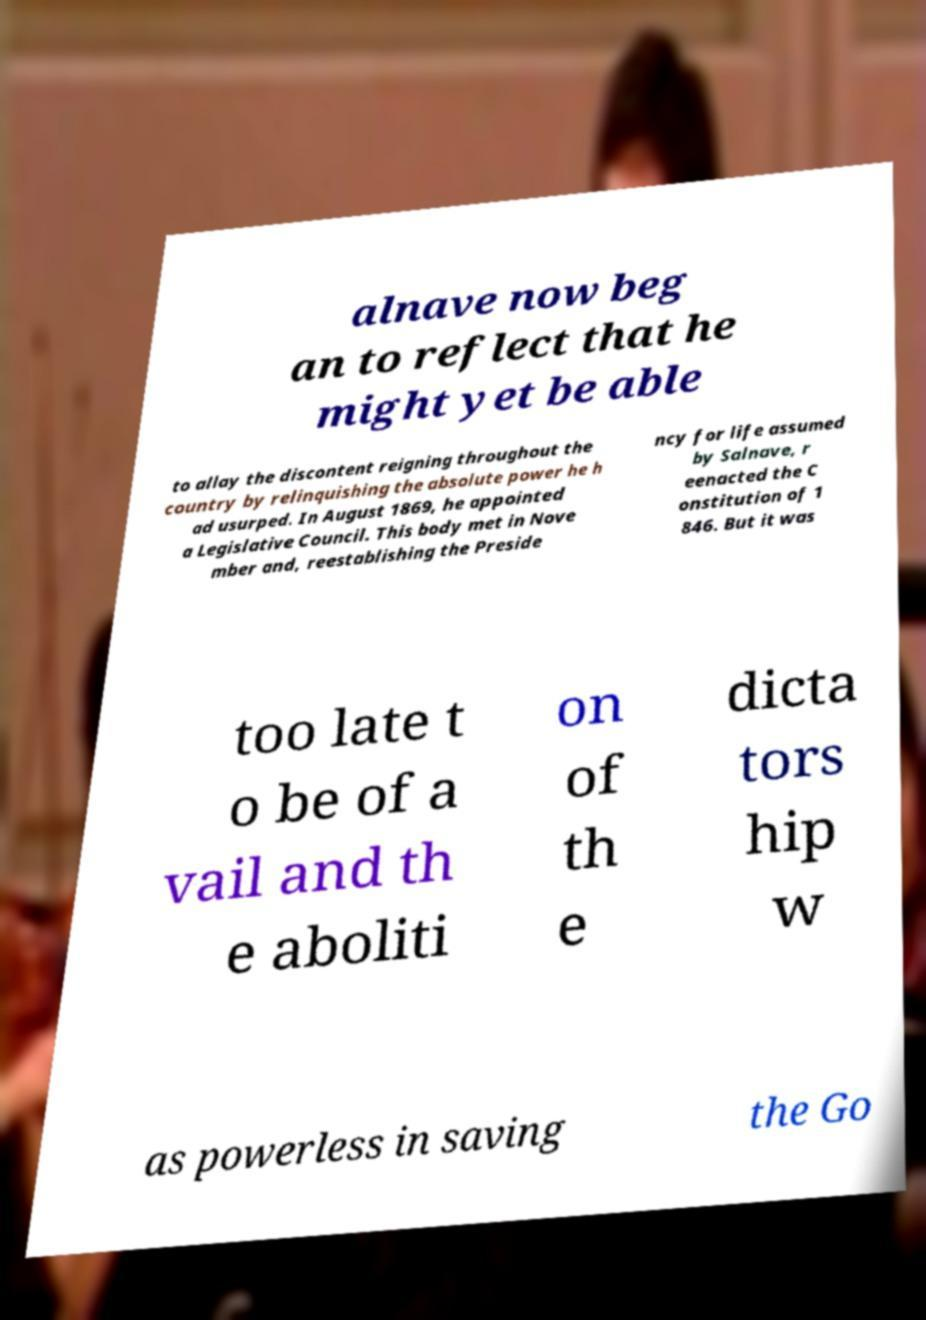Can you read and provide the text displayed in the image?This photo seems to have some interesting text. Can you extract and type it out for me? alnave now beg an to reflect that he might yet be able to allay the discontent reigning throughout the country by relinquishing the absolute power he h ad usurped. In August 1869, he appointed a Legislative Council. This body met in Nove mber and, reestablishing the Preside ncy for life assumed by Salnave, r eenacted the C onstitution of 1 846. But it was too late t o be of a vail and th e aboliti on of th e dicta tors hip w as powerless in saving the Go 